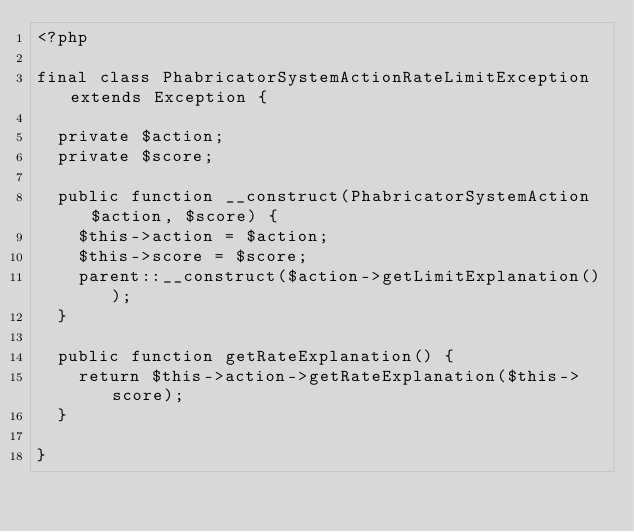<code> <loc_0><loc_0><loc_500><loc_500><_PHP_><?php

final class PhabricatorSystemActionRateLimitException extends Exception {

  private $action;
  private $score;

  public function __construct(PhabricatorSystemAction $action, $score) {
    $this->action = $action;
    $this->score = $score;
    parent::__construct($action->getLimitExplanation());
  }

  public function getRateExplanation() {
    return $this->action->getRateExplanation($this->score);
  }

}
</code> 